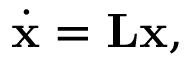Convert formula to latex. <formula><loc_0><loc_0><loc_500><loc_500>\dot { x } = L x ,</formula> 